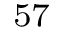<formula> <loc_0><loc_0><loc_500><loc_500>^ { 5 7 }</formula> 